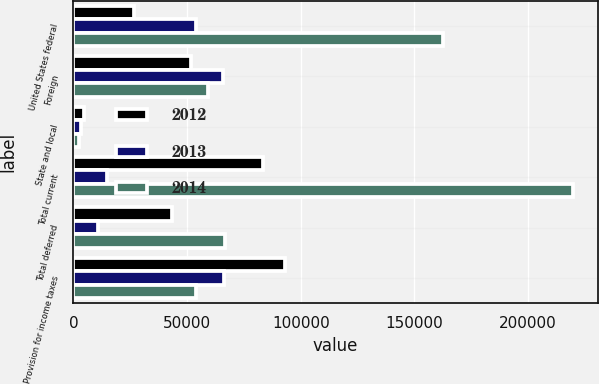<chart> <loc_0><loc_0><loc_500><loc_500><stacked_bar_chart><ecel><fcel>United States federal<fcel>Foreign<fcel>State and local<fcel>Total current<fcel>Total deferred<fcel>Provision for income taxes<nl><fcel>2012<fcel>26822<fcel>51684<fcel>4713<fcel>83219<fcel>43461<fcel>92981<nl><fcel>2013<fcel>53985<fcel>65609<fcel>3317<fcel>14941<fcel>10596<fcel>66156<nl><fcel>2014<fcel>162574<fcel>59255<fcel>2244<fcel>219585<fcel>66434<fcel>53985<nl></chart> 